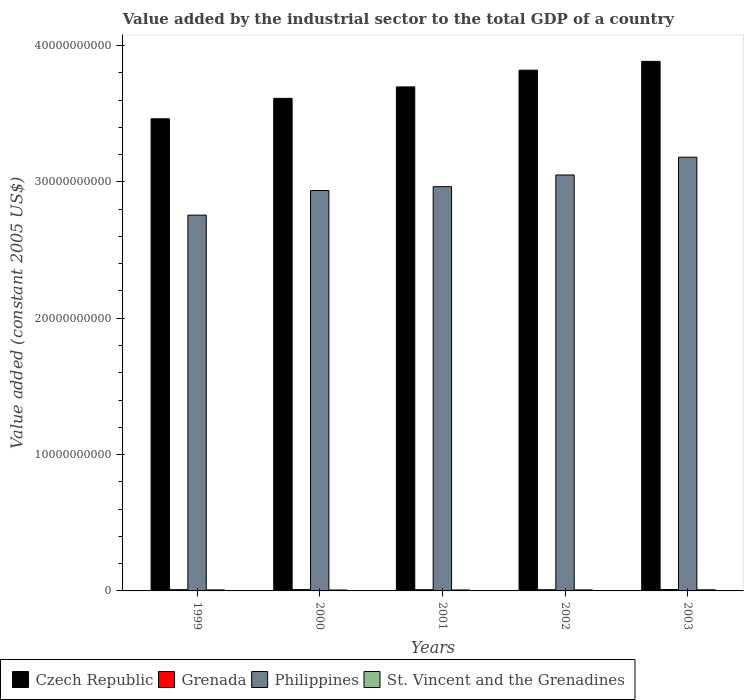How many different coloured bars are there?
Keep it short and to the point. 4. How many groups of bars are there?
Your answer should be very brief. 5. Are the number of bars per tick equal to the number of legend labels?
Offer a terse response. Yes. How many bars are there on the 4th tick from the left?
Offer a very short reply. 4. How many bars are there on the 5th tick from the right?
Your response must be concise. 4. What is the label of the 1st group of bars from the left?
Offer a very short reply. 1999. In how many cases, is the number of bars for a given year not equal to the number of legend labels?
Offer a terse response. 0. What is the value added by the industrial sector in Grenada in 2003?
Your answer should be compact. 1.01e+08. Across all years, what is the maximum value added by the industrial sector in St. Vincent and the Grenadines?
Offer a very short reply. 8.26e+07. Across all years, what is the minimum value added by the industrial sector in Czech Republic?
Give a very brief answer. 3.46e+1. In which year was the value added by the industrial sector in Grenada maximum?
Your answer should be compact. 2003. What is the total value added by the industrial sector in Czech Republic in the graph?
Your answer should be compact. 1.85e+11. What is the difference between the value added by the industrial sector in St. Vincent and the Grenadines in 1999 and that in 2002?
Your answer should be very brief. 2.57e+06. What is the difference between the value added by the industrial sector in Grenada in 2001 and the value added by the industrial sector in Czech Republic in 2002?
Provide a succinct answer. -3.81e+1. What is the average value added by the industrial sector in Grenada per year?
Your response must be concise. 9.32e+07. In the year 2002, what is the difference between the value added by the industrial sector in Philippines and value added by the industrial sector in St. Vincent and the Grenadines?
Provide a short and direct response. 3.04e+1. In how many years, is the value added by the industrial sector in Philippines greater than 20000000000 US$?
Your response must be concise. 5. What is the ratio of the value added by the industrial sector in Grenada in 2001 to that in 2002?
Your answer should be very brief. 0.98. Is the value added by the industrial sector in St. Vincent and the Grenadines in 1999 less than that in 2002?
Provide a short and direct response. No. Is the difference between the value added by the industrial sector in Philippines in 1999 and 2002 greater than the difference between the value added by the industrial sector in St. Vincent and the Grenadines in 1999 and 2002?
Your answer should be very brief. No. What is the difference between the highest and the second highest value added by the industrial sector in Grenada?
Offer a very short reply. 5.77e+06. What is the difference between the highest and the lowest value added by the industrial sector in Philippines?
Keep it short and to the point. 4.25e+09. In how many years, is the value added by the industrial sector in Philippines greater than the average value added by the industrial sector in Philippines taken over all years?
Keep it short and to the point. 2. Is it the case that in every year, the sum of the value added by the industrial sector in Grenada and value added by the industrial sector in St. Vincent and the Grenadines is greater than the sum of value added by the industrial sector in Philippines and value added by the industrial sector in Czech Republic?
Your answer should be compact. Yes. What does the 2nd bar from the left in 2001 represents?
Ensure brevity in your answer.  Grenada. What does the 1st bar from the right in 1999 represents?
Your response must be concise. St. Vincent and the Grenadines. How many bars are there?
Ensure brevity in your answer.  20. Does the graph contain any zero values?
Give a very brief answer. No. Where does the legend appear in the graph?
Make the answer very short. Bottom left. How many legend labels are there?
Offer a very short reply. 4. How are the legend labels stacked?
Give a very brief answer. Horizontal. What is the title of the graph?
Your response must be concise. Value added by the industrial sector to the total GDP of a country. What is the label or title of the X-axis?
Give a very brief answer. Years. What is the label or title of the Y-axis?
Offer a terse response. Value added (constant 2005 US$). What is the Value added (constant 2005 US$) in Czech Republic in 1999?
Your answer should be compact. 3.46e+1. What is the Value added (constant 2005 US$) of Grenada in 1999?
Your response must be concise. 9.29e+07. What is the Value added (constant 2005 US$) of Philippines in 1999?
Your response must be concise. 2.76e+1. What is the Value added (constant 2005 US$) in St. Vincent and the Grenadines in 1999?
Make the answer very short. 7.55e+07. What is the Value added (constant 2005 US$) of Czech Republic in 2000?
Give a very brief answer. 3.61e+1. What is the Value added (constant 2005 US$) in Grenada in 2000?
Give a very brief answer. 9.56e+07. What is the Value added (constant 2005 US$) in Philippines in 2000?
Offer a very short reply. 2.94e+1. What is the Value added (constant 2005 US$) of St. Vincent and the Grenadines in 2000?
Provide a succinct answer. 6.92e+07. What is the Value added (constant 2005 US$) in Czech Republic in 2001?
Your answer should be very brief. 3.70e+1. What is the Value added (constant 2005 US$) in Grenada in 2001?
Your response must be concise. 8.70e+07. What is the Value added (constant 2005 US$) of Philippines in 2001?
Make the answer very short. 2.96e+1. What is the Value added (constant 2005 US$) in St. Vincent and the Grenadines in 2001?
Ensure brevity in your answer.  7.03e+07. What is the Value added (constant 2005 US$) of Czech Republic in 2002?
Your answer should be compact. 3.82e+1. What is the Value added (constant 2005 US$) in Grenada in 2002?
Offer a very short reply. 8.91e+07. What is the Value added (constant 2005 US$) in Philippines in 2002?
Give a very brief answer. 3.05e+1. What is the Value added (constant 2005 US$) of St. Vincent and the Grenadines in 2002?
Your answer should be compact. 7.29e+07. What is the Value added (constant 2005 US$) in Czech Republic in 2003?
Provide a short and direct response. 3.88e+1. What is the Value added (constant 2005 US$) in Grenada in 2003?
Keep it short and to the point. 1.01e+08. What is the Value added (constant 2005 US$) of Philippines in 2003?
Your response must be concise. 3.18e+1. What is the Value added (constant 2005 US$) in St. Vincent and the Grenadines in 2003?
Your response must be concise. 8.26e+07. Across all years, what is the maximum Value added (constant 2005 US$) in Czech Republic?
Give a very brief answer. 3.88e+1. Across all years, what is the maximum Value added (constant 2005 US$) in Grenada?
Ensure brevity in your answer.  1.01e+08. Across all years, what is the maximum Value added (constant 2005 US$) in Philippines?
Your response must be concise. 3.18e+1. Across all years, what is the maximum Value added (constant 2005 US$) of St. Vincent and the Grenadines?
Your answer should be compact. 8.26e+07. Across all years, what is the minimum Value added (constant 2005 US$) of Czech Republic?
Ensure brevity in your answer.  3.46e+1. Across all years, what is the minimum Value added (constant 2005 US$) in Grenada?
Ensure brevity in your answer.  8.70e+07. Across all years, what is the minimum Value added (constant 2005 US$) of Philippines?
Make the answer very short. 2.76e+1. Across all years, what is the minimum Value added (constant 2005 US$) in St. Vincent and the Grenadines?
Keep it short and to the point. 6.92e+07. What is the total Value added (constant 2005 US$) in Czech Republic in the graph?
Offer a very short reply. 1.85e+11. What is the total Value added (constant 2005 US$) in Grenada in the graph?
Keep it short and to the point. 4.66e+08. What is the total Value added (constant 2005 US$) of Philippines in the graph?
Your answer should be very brief. 1.49e+11. What is the total Value added (constant 2005 US$) in St. Vincent and the Grenadines in the graph?
Keep it short and to the point. 3.71e+08. What is the difference between the Value added (constant 2005 US$) of Czech Republic in 1999 and that in 2000?
Your answer should be compact. -1.50e+09. What is the difference between the Value added (constant 2005 US$) of Grenada in 1999 and that in 2000?
Give a very brief answer. -2.69e+06. What is the difference between the Value added (constant 2005 US$) of Philippines in 1999 and that in 2000?
Ensure brevity in your answer.  -1.80e+09. What is the difference between the Value added (constant 2005 US$) of St. Vincent and the Grenadines in 1999 and that in 2000?
Provide a short and direct response. 6.26e+06. What is the difference between the Value added (constant 2005 US$) in Czech Republic in 1999 and that in 2001?
Keep it short and to the point. -2.34e+09. What is the difference between the Value added (constant 2005 US$) of Grenada in 1999 and that in 2001?
Offer a very short reply. 5.90e+06. What is the difference between the Value added (constant 2005 US$) in Philippines in 1999 and that in 2001?
Offer a very short reply. -2.09e+09. What is the difference between the Value added (constant 2005 US$) in St. Vincent and the Grenadines in 1999 and that in 2001?
Your answer should be compact. 5.14e+06. What is the difference between the Value added (constant 2005 US$) in Czech Republic in 1999 and that in 2002?
Your answer should be very brief. -3.57e+09. What is the difference between the Value added (constant 2005 US$) in Grenada in 1999 and that in 2002?
Your response must be concise. 3.80e+06. What is the difference between the Value added (constant 2005 US$) of Philippines in 1999 and that in 2002?
Your response must be concise. -2.94e+09. What is the difference between the Value added (constant 2005 US$) in St. Vincent and the Grenadines in 1999 and that in 2002?
Ensure brevity in your answer.  2.57e+06. What is the difference between the Value added (constant 2005 US$) of Czech Republic in 1999 and that in 2003?
Provide a succinct answer. -4.21e+09. What is the difference between the Value added (constant 2005 US$) in Grenada in 1999 and that in 2003?
Provide a short and direct response. -8.46e+06. What is the difference between the Value added (constant 2005 US$) of Philippines in 1999 and that in 2003?
Give a very brief answer. -4.25e+09. What is the difference between the Value added (constant 2005 US$) in St. Vincent and the Grenadines in 1999 and that in 2003?
Provide a succinct answer. -7.10e+06. What is the difference between the Value added (constant 2005 US$) in Czech Republic in 2000 and that in 2001?
Offer a terse response. -8.39e+08. What is the difference between the Value added (constant 2005 US$) in Grenada in 2000 and that in 2001?
Provide a short and direct response. 8.59e+06. What is the difference between the Value added (constant 2005 US$) in Philippines in 2000 and that in 2001?
Ensure brevity in your answer.  -2.82e+08. What is the difference between the Value added (constant 2005 US$) of St. Vincent and the Grenadines in 2000 and that in 2001?
Offer a very short reply. -1.12e+06. What is the difference between the Value added (constant 2005 US$) in Czech Republic in 2000 and that in 2002?
Ensure brevity in your answer.  -2.07e+09. What is the difference between the Value added (constant 2005 US$) of Grenada in 2000 and that in 2002?
Your response must be concise. 6.49e+06. What is the difference between the Value added (constant 2005 US$) of Philippines in 2000 and that in 2002?
Offer a very short reply. -1.14e+09. What is the difference between the Value added (constant 2005 US$) in St. Vincent and the Grenadines in 2000 and that in 2002?
Provide a short and direct response. -3.69e+06. What is the difference between the Value added (constant 2005 US$) in Czech Republic in 2000 and that in 2003?
Ensure brevity in your answer.  -2.71e+09. What is the difference between the Value added (constant 2005 US$) in Grenada in 2000 and that in 2003?
Keep it short and to the point. -5.77e+06. What is the difference between the Value added (constant 2005 US$) of Philippines in 2000 and that in 2003?
Offer a terse response. -2.44e+09. What is the difference between the Value added (constant 2005 US$) of St. Vincent and the Grenadines in 2000 and that in 2003?
Your answer should be compact. -1.34e+07. What is the difference between the Value added (constant 2005 US$) in Czech Republic in 2001 and that in 2002?
Provide a succinct answer. -1.23e+09. What is the difference between the Value added (constant 2005 US$) of Grenada in 2001 and that in 2002?
Your answer should be compact. -2.10e+06. What is the difference between the Value added (constant 2005 US$) of Philippines in 2001 and that in 2002?
Ensure brevity in your answer.  -8.57e+08. What is the difference between the Value added (constant 2005 US$) of St. Vincent and the Grenadines in 2001 and that in 2002?
Offer a terse response. -2.58e+06. What is the difference between the Value added (constant 2005 US$) in Czech Republic in 2001 and that in 2003?
Keep it short and to the point. -1.87e+09. What is the difference between the Value added (constant 2005 US$) in Grenada in 2001 and that in 2003?
Your answer should be very brief. -1.44e+07. What is the difference between the Value added (constant 2005 US$) in Philippines in 2001 and that in 2003?
Your answer should be very brief. -2.16e+09. What is the difference between the Value added (constant 2005 US$) of St. Vincent and the Grenadines in 2001 and that in 2003?
Provide a short and direct response. -1.22e+07. What is the difference between the Value added (constant 2005 US$) in Czech Republic in 2002 and that in 2003?
Ensure brevity in your answer.  -6.47e+08. What is the difference between the Value added (constant 2005 US$) in Grenada in 2002 and that in 2003?
Keep it short and to the point. -1.23e+07. What is the difference between the Value added (constant 2005 US$) of Philippines in 2002 and that in 2003?
Ensure brevity in your answer.  -1.30e+09. What is the difference between the Value added (constant 2005 US$) of St. Vincent and the Grenadines in 2002 and that in 2003?
Give a very brief answer. -9.67e+06. What is the difference between the Value added (constant 2005 US$) in Czech Republic in 1999 and the Value added (constant 2005 US$) in Grenada in 2000?
Your answer should be very brief. 3.45e+1. What is the difference between the Value added (constant 2005 US$) in Czech Republic in 1999 and the Value added (constant 2005 US$) in Philippines in 2000?
Provide a succinct answer. 5.26e+09. What is the difference between the Value added (constant 2005 US$) of Czech Republic in 1999 and the Value added (constant 2005 US$) of St. Vincent and the Grenadines in 2000?
Ensure brevity in your answer.  3.46e+1. What is the difference between the Value added (constant 2005 US$) in Grenada in 1999 and the Value added (constant 2005 US$) in Philippines in 2000?
Ensure brevity in your answer.  -2.93e+1. What is the difference between the Value added (constant 2005 US$) in Grenada in 1999 and the Value added (constant 2005 US$) in St. Vincent and the Grenadines in 2000?
Offer a very short reply. 2.37e+07. What is the difference between the Value added (constant 2005 US$) of Philippines in 1999 and the Value added (constant 2005 US$) of St. Vincent and the Grenadines in 2000?
Offer a terse response. 2.75e+1. What is the difference between the Value added (constant 2005 US$) in Czech Republic in 1999 and the Value added (constant 2005 US$) in Grenada in 2001?
Provide a succinct answer. 3.45e+1. What is the difference between the Value added (constant 2005 US$) of Czech Republic in 1999 and the Value added (constant 2005 US$) of Philippines in 2001?
Provide a succinct answer. 4.98e+09. What is the difference between the Value added (constant 2005 US$) in Czech Republic in 1999 and the Value added (constant 2005 US$) in St. Vincent and the Grenadines in 2001?
Your answer should be very brief. 3.46e+1. What is the difference between the Value added (constant 2005 US$) of Grenada in 1999 and the Value added (constant 2005 US$) of Philippines in 2001?
Keep it short and to the point. -2.96e+1. What is the difference between the Value added (constant 2005 US$) in Grenada in 1999 and the Value added (constant 2005 US$) in St. Vincent and the Grenadines in 2001?
Your response must be concise. 2.26e+07. What is the difference between the Value added (constant 2005 US$) in Philippines in 1999 and the Value added (constant 2005 US$) in St. Vincent and the Grenadines in 2001?
Provide a short and direct response. 2.75e+1. What is the difference between the Value added (constant 2005 US$) of Czech Republic in 1999 and the Value added (constant 2005 US$) of Grenada in 2002?
Offer a very short reply. 3.45e+1. What is the difference between the Value added (constant 2005 US$) in Czech Republic in 1999 and the Value added (constant 2005 US$) in Philippines in 2002?
Your response must be concise. 4.12e+09. What is the difference between the Value added (constant 2005 US$) in Czech Republic in 1999 and the Value added (constant 2005 US$) in St. Vincent and the Grenadines in 2002?
Offer a very short reply. 3.46e+1. What is the difference between the Value added (constant 2005 US$) in Grenada in 1999 and the Value added (constant 2005 US$) in Philippines in 2002?
Offer a very short reply. -3.04e+1. What is the difference between the Value added (constant 2005 US$) in Grenada in 1999 and the Value added (constant 2005 US$) in St. Vincent and the Grenadines in 2002?
Your answer should be compact. 2.00e+07. What is the difference between the Value added (constant 2005 US$) in Philippines in 1999 and the Value added (constant 2005 US$) in St. Vincent and the Grenadines in 2002?
Your answer should be compact. 2.75e+1. What is the difference between the Value added (constant 2005 US$) in Czech Republic in 1999 and the Value added (constant 2005 US$) in Grenada in 2003?
Ensure brevity in your answer.  3.45e+1. What is the difference between the Value added (constant 2005 US$) of Czech Republic in 1999 and the Value added (constant 2005 US$) of Philippines in 2003?
Give a very brief answer. 2.82e+09. What is the difference between the Value added (constant 2005 US$) in Czech Republic in 1999 and the Value added (constant 2005 US$) in St. Vincent and the Grenadines in 2003?
Give a very brief answer. 3.45e+1. What is the difference between the Value added (constant 2005 US$) in Grenada in 1999 and the Value added (constant 2005 US$) in Philippines in 2003?
Your response must be concise. -3.17e+1. What is the difference between the Value added (constant 2005 US$) of Grenada in 1999 and the Value added (constant 2005 US$) of St. Vincent and the Grenadines in 2003?
Your answer should be compact. 1.03e+07. What is the difference between the Value added (constant 2005 US$) of Philippines in 1999 and the Value added (constant 2005 US$) of St. Vincent and the Grenadines in 2003?
Provide a short and direct response. 2.75e+1. What is the difference between the Value added (constant 2005 US$) in Czech Republic in 2000 and the Value added (constant 2005 US$) in Grenada in 2001?
Your answer should be very brief. 3.60e+1. What is the difference between the Value added (constant 2005 US$) of Czech Republic in 2000 and the Value added (constant 2005 US$) of Philippines in 2001?
Your answer should be compact. 6.48e+09. What is the difference between the Value added (constant 2005 US$) in Czech Republic in 2000 and the Value added (constant 2005 US$) in St. Vincent and the Grenadines in 2001?
Your response must be concise. 3.61e+1. What is the difference between the Value added (constant 2005 US$) in Grenada in 2000 and the Value added (constant 2005 US$) in Philippines in 2001?
Keep it short and to the point. -2.96e+1. What is the difference between the Value added (constant 2005 US$) of Grenada in 2000 and the Value added (constant 2005 US$) of St. Vincent and the Grenadines in 2001?
Your answer should be very brief. 2.52e+07. What is the difference between the Value added (constant 2005 US$) in Philippines in 2000 and the Value added (constant 2005 US$) in St. Vincent and the Grenadines in 2001?
Provide a short and direct response. 2.93e+1. What is the difference between the Value added (constant 2005 US$) of Czech Republic in 2000 and the Value added (constant 2005 US$) of Grenada in 2002?
Provide a short and direct response. 3.60e+1. What is the difference between the Value added (constant 2005 US$) of Czech Republic in 2000 and the Value added (constant 2005 US$) of Philippines in 2002?
Offer a terse response. 5.62e+09. What is the difference between the Value added (constant 2005 US$) in Czech Republic in 2000 and the Value added (constant 2005 US$) in St. Vincent and the Grenadines in 2002?
Provide a succinct answer. 3.60e+1. What is the difference between the Value added (constant 2005 US$) of Grenada in 2000 and the Value added (constant 2005 US$) of Philippines in 2002?
Your response must be concise. -3.04e+1. What is the difference between the Value added (constant 2005 US$) in Grenada in 2000 and the Value added (constant 2005 US$) in St. Vincent and the Grenadines in 2002?
Keep it short and to the point. 2.27e+07. What is the difference between the Value added (constant 2005 US$) of Philippines in 2000 and the Value added (constant 2005 US$) of St. Vincent and the Grenadines in 2002?
Ensure brevity in your answer.  2.93e+1. What is the difference between the Value added (constant 2005 US$) in Czech Republic in 2000 and the Value added (constant 2005 US$) in Grenada in 2003?
Your answer should be compact. 3.60e+1. What is the difference between the Value added (constant 2005 US$) in Czech Republic in 2000 and the Value added (constant 2005 US$) in Philippines in 2003?
Give a very brief answer. 4.32e+09. What is the difference between the Value added (constant 2005 US$) in Czech Republic in 2000 and the Value added (constant 2005 US$) in St. Vincent and the Grenadines in 2003?
Your answer should be very brief. 3.60e+1. What is the difference between the Value added (constant 2005 US$) of Grenada in 2000 and the Value added (constant 2005 US$) of Philippines in 2003?
Offer a terse response. -3.17e+1. What is the difference between the Value added (constant 2005 US$) in Grenada in 2000 and the Value added (constant 2005 US$) in St. Vincent and the Grenadines in 2003?
Offer a terse response. 1.30e+07. What is the difference between the Value added (constant 2005 US$) of Philippines in 2000 and the Value added (constant 2005 US$) of St. Vincent and the Grenadines in 2003?
Make the answer very short. 2.93e+1. What is the difference between the Value added (constant 2005 US$) of Czech Republic in 2001 and the Value added (constant 2005 US$) of Grenada in 2002?
Keep it short and to the point. 3.69e+1. What is the difference between the Value added (constant 2005 US$) in Czech Republic in 2001 and the Value added (constant 2005 US$) in Philippines in 2002?
Offer a terse response. 6.46e+09. What is the difference between the Value added (constant 2005 US$) of Czech Republic in 2001 and the Value added (constant 2005 US$) of St. Vincent and the Grenadines in 2002?
Give a very brief answer. 3.69e+1. What is the difference between the Value added (constant 2005 US$) of Grenada in 2001 and the Value added (constant 2005 US$) of Philippines in 2002?
Your answer should be very brief. -3.04e+1. What is the difference between the Value added (constant 2005 US$) of Grenada in 2001 and the Value added (constant 2005 US$) of St. Vincent and the Grenadines in 2002?
Offer a terse response. 1.41e+07. What is the difference between the Value added (constant 2005 US$) of Philippines in 2001 and the Value added (constant 2005 US$) of St. Vincent and the Grenadines in 2002?
Offer a terse response. 2.96e+1. What is the difference between the Value added (constant 2005 US$) in Czech Republic in 2001 and the Value added (constant 2005 US$) in Grenada in 2003?
Offer a very short reply. 3.69e+1. What is the difference between the Value added (constant 2005 US$) of Czech Republic in 2001 and the Value added (constant 2005 US$) of Philippines in 2003?
Keep it short and to the point. 5.16e+09. What is the difference between the Value added (constant 2005 US$) in Czech Republic in 2001 and the Value added (constant 2005 US$) in St. Vincent and the Grenadines in 2003?
Offer a very short reply. 3.69e+1. What is the difference between the Value added (constant 2005 US$) of Grenada in 2001 and the Value added (constant 2005 US$) of Philippines in 2003?
Give a very brief answer. -3.17e+1. What is the difference between the Value added (constant 2005 US$) of Grenada in 2001 and the Value added (constant 2005 US$) of St. Vincent and the Grenadines in 2003?
Your answer should be very brief. 4.41e+06. What is the difference between the Value added (constant 2005 US$) in Philippines in 2001 and the Value added (constant 2005 US$) in St. Vincent and the Grenadines in 2003?
Offer a terse response. 2.96e+1. What is the difference between the Value added (constant 2005 US$) in Czech Republic in 2002 and the Value added (constant 2005 US$) in Grenada in 2003?
Provide a short and direct response. 3.81e+1. What is the difference between the Value added (constant 2005 US$) in Czech Republic in 2002 and the Value added (constant 2005 US$) in Philippines in 2003?
Provide a succinct answer. 6.38e+09. What is the difference between the Value added (constant 2005 US$) in Czech Republic in 2002 and the Value added (constant 2005 US$) in St. Vincent and the Grenadines in 2003?
Your response must be concise. 3.81e+1. What is the difference between the Value added (constant 2005 US$) of Grenada in 2002 and the Value added (constant 2005 US$) of Philippines in 2003?
Make the answer very short. -3.17e+1. What is the difference between the Value added (constant 2005 US$) of Grenada in 2002 and the Value added (constant 2005 US$) of St. Vincent and the Grenadines in 2003?
Provide a short and direct response. 6.51e+06. What is the difference between the Value added (constant 2005 US$) of Philippines in 2002 and the Value added (constant 2005 US$) of St. Vincent and the Grenadines in 2003?
Make the answer very short. 3.04e+1. What is the average Value added (constant 2005 US$) in Czech Republic per year?
Provide a succinct answer. 3.69e+1. What is the average Value added (constant 2005 US$) of Grenada per year?
Provide a short and direct response. 9.32e+07. What is the average Value added (constant 2005 US$) of Philippines per year?
Provide a short and direct response. 2.98e+1. What is the average Value added (constant 2005 US$) of St. Vincent and the Grenadines per year?
Offer a terse response. 7.41e+07. In the year 1999, what is the difference between the Value added (constant 2005 US$) in Czech Republic and Value added (constant 2005 US$) in Grenada?
Offer a very short reply. 3.45e+1. In the year 1999, what is the difference between the Value added (constant 2005 US$) of Czech Republic and Value added (constant 2005 US$) of Philippines?
Give a very brief answer. 7.06e+09. In the year 1999, what is the difference between the Value added (constant 2005 US$) of Czech Republic and Value added (constant 2005 US$) of St. Vincent and the Grenadines?
Make the answer very short. 3.45e+1. In the year 1999, what is the difference between the Value added (constant 2005 US$) in Grenada and Value added (constant 2005 US$) in Philippines?
Your answer should be very brief. -2.75e+1. In the year 1999, what is the difference between the Value added (constant 2005 US$) in Grenada and Value added (constant 2005 US$) in St. Vincent and the Grenadines?
Your response must be concise. 1.74e+07. In the year 1999, what is the difference between the Value added (constant 2005 US$) of Philippines and Value added (constant 2005 US$) of St. Vincent and the Grenadines?
Your response must be concise. 2.75e+1. In the year 2000, what is the difference between the Value added (constant 2005 US$) in Czech Republic and Value added (constant 2005 US$) in Grenada?
Provide a succinct answer. 3.60e+1. In the year 2000, what is the difference between the Value added (constant 2005 US$) in Czech Republic and Value added (constant 2005 US$) in Philippines?
Keep it short and to the point. 6.76e+09. In the year 2000, what is the difference between the Value added (constant 2005 US$) in Czech Republic and Value added (constant 2005 US$) in St. Vincent and the Grenadines?
Make the answer very short. 3.61e+1. In the year 2000, what is the difference between the Value added (constant 2005 US$) of Grenada and Value added (constant 2005 US$) of Philippines?
Ensure brevity in your answer.  -2.93e+1. In the year 2000, what is the difference between the Value added (constant 2005 US$) of Grenada and Value added (constant 2005 US$) of St. Vincent and the Grenadines?
Your answer should be very brief. 2.64e+07. In the year 2000, what is the difference between the Value added (constant 2005 US$) of Philippines and Value added (constant 2005 US$) of St. Vincent and the Grenadines?
Keep it short and to the point. 2.93e+1. In the year 2001, what is the difference between the Value added (constant 2005 US$) in Czech Republic and Value added (constant 2005 US$) in Grenada?
Make the answer very short. 3.69e+1. In the year 2001, what is the difference between the Value added (constant 2005 US$) in Czech Republic and Value added (constant 2005 US$) in Philippines?
Offer a very short reply. 7.32e+09. In the year 2001, what is the difference between the Value added (constant 2005 US$) in Czech Republic and Value added (constant 2005 US$) in St. Vincent and the Grenadines?
Ensure brevity in your answer.  3.69e+1. In the year 2001, what is the difference between the Value added (constant 2005 US$) of Grenada and Value added (constant 2005 US$) of Philippines?
Ensure brevity in your answer.  -2.96e+1. In the year 2001, what is the difference between the Value added (constant 2005 US$) in Grenada and Value added (constant 2005 US$) in St. Vincent and the Grenadines?
Give a very brief answer. 1.67e+07. In the year 2001, what is the difference between the Value added (constant 2005 US$) of Philippines and Value added (constant 2005 US$) of St. Vincent and the Grenadines?
Ensure brevity in your answer.  2.96e+1. In the year 2002, what is the difference between the Value added (constant 2005 US$) in Czech Republic and Value added (constant 2005 US$) in Grenada?
Your response must be concise. 3.81e+1. In the year 2002, what is the difference between the Value added (constant 2005 US$) in Czech Republic and Value added (constant 2005 US$) in Philippines?
Give a very brief answer. 7.69e+09. In the year 2002, what is the difference between the Value added (constant 2005 US$) in Czech Republic and Value added (constant 2005 US$) in St. Vincent and the Grenadines?
Provide a succinct answer. 3.81e+1. In the year 2002, what is the difference between the Value added (constant 2005 US$) in Grenada and Value added (constant 2005 US$) in Philippines?
Your response must be concise. -3.04e+1. In the year 2002, what is the difference between the Value added (constant 2005 US$) in Grenada and Value added (constant 2005 US$) in St. Vincent and the Grenadines?
Make the answer very short. 1.62e+07. In the year 2002, what is the difference between the Value added (constant 2005 US$) of Philippines and Value added (constant 2005 US$) of St. Vincent and the Grenadines?
Give a very brief answer. 3.04e+1. In the year 2003, what is the difference between the Value added (constant 2005 US$) in Czech Republic and Value added (constant 2005 US$) in Grenada?
Provide a succinct answer. 3.87e+1. In the year 2003, what is the difference between the Value added (constant 2005 US$) in Czech Republic and Value added (constant 2005 US$) in Philippines?
Offer a very short reply. 7.03e+09. In the year 2003, what is the difference between the Value added (constant 2005 US$) in Czech Republic and Value added (constant 2005 US$) in St. Vincent and the Grenadines?
Provide a short and direct response. 3.88e+1. In the year 2003, what is the difference between the Value added (constant 2005 US$) in Grenada and Value added (constant 2005 US$) in Philippines?
Ensure brevity in your answer.  -3.17e+1. In the year 2003, what is the difference between the Value added (constant 2005 US$) of Grenada and Value added (constant 2005 US$) of St. Vincent and the Grenadines?
Offer a terse response. 1.88e+07. In the year 2003, what is the difference between the Value added (constant 2005 US$) of Philippines and Value added (constant 2005 US$) of St. Vincent and the Grenadines?
Provide a short and direct response. 3.17e+1. What is the ratio of the Value added (constant 2005 US$) of Czech Republic in 1999 to that in 2000?
Ensure brevity in your answer.  0.96. What is the ratio of the Value added (constant 2005 US$) in Grenada in 1999 to that in 2000?
Keep it short and to the point. 0.97. What is the ratio of the Value added (constant 2005 US$) of Philippines in 1999 to that in 2000?
Make the answer very short. 0.94. What is the ratio of the Value added (constant 2005 US$) in St. Vincent and the Grenadines in 1999 to that in 2000?
Your answer should be compact. 1.09. What is the ratio of the Value added (constant 2005 US$) in Czech Republic in 1999 to that in 2001?
Provide a short and direct response. 0.94. What is the ratio of the Value added (constant 2005 US$) of Grenada in 1999 to that in 2001?
Offer a very short reply. 1.07. What is the ratio of the Value added (constant 2005 US$) of Philippines in 1999 to that in 2001?
Your answer should be compact. 0.93. What is the ratio of the Value added (constant 2005 US$) of St. Vincent and the Grenadines in 1999 to that in 2001?
Your response must be concise. 1.07. What is the ratio of the Value added (constant 2005 US$) in Czech Republic in 1999 to that in 2002?
Your response must be concise. 0.91. What is the ratio of the Value added (constant 2005 US$) in Grenada in 1999 to that in 2002?
Provide a succinct answer. 1.04. What is the ratio of the Value added (constant 2005 US$) of Philippines in 1999 to that in 2002?
Give a very brief answer. 0.9. What is the ratio of the Value added (constant 2005 US$) of St. Vincent and the Grenadines in 1999 to that in 2002?
Give a very brief answer. 1.04. What is the ratio of the Value added (constant 2005 US$) of Czech Republic in 1999 to that in 2003?
Keep it short and to the point. 0.89. What is the ratio of the Value added (constant 2005 US$) of Grenada in 1999 to that in 2003?
Offer a very short reply. 0.92. What is the ratio of the Value added (constant 2005 US$) in Philippines in 1999 to that in 2003?
Ensure brevity in your answer.  0.87. What is the ratio of the Value added (constant 2005 US$) in St. Vincent and the Grenadines in 1999 to that in 2003?
Offer a terse response. 0.91. What is the ratio of the Value added (constant 2005 US$) of Czech Republic in 2000 to that in 2001?
Your answer should be very brief. 0.98. What is the ratio of the Value added (constant 2005 US$) in Grenada in 2000 to that in 2001?
Your answer should be compact. 1.1. What is the ratio of the Value added (constant 2005 US$) of Philippines in 2000 to that in 2001?
Keep it short and to the point. 0.99. What is the ratio of the Value added (constant 2005 US$) in St. Vincent and the Grenadines in 2000 to that in 2001?
Keep it short and to the point. 0.98. What is the ratio of the Value added (constant 2005 US$) in Czech Republic in 2000 to that in 2002?
Your answer should be very brief. 0.95. What is the ratio of the Value added (constant 2005 US$) in Grenada in 2000 to that in 2002?
Offer a very short reply. 1.07. What is the ratio of the Value added (constant 2005 US$) in Philippines in 2000 to that in 2002?
Keep it short and to the point. 0.96. What is the ratio of the Value added (constant 2005 US$) in St. Vincent and the Grenadines in 2000 to that in 2002?
Your answer should be compact. 0.95. What is the ratio of the Value added (constant 2005 US$) of Czech Republic in 2000 to that in 2003?
Your answer should be compact. 0.93. What is the ratio of the Value added (constant 2005 US$) of Grenada in 2000 to that in 2003?
Keep it short and to the point. 0.94. What is the ratio of the Value added (constant 2005 US$) in Philippines in 2000 to that in 2003?
Your answer should be compact. 0.92. What is the ratio of the Value added (constant 2005 US$) in St. Vincent and the Grenadines in 2000 to that in 2003?
Make the answer very short. 0.84. What is the ratio of the Value added (constant 2005 US$) in Czech Republic in 2001 to that in 2002?
Provide a short and direct response. 0.97. What is the ratio of the Value added (constant 2005 US$) in Grenada in 2001 to that in 2002?
Offer a terse response. 0.98. What is the ratio of the Value added (constant 2005 US$) in Philippines in 2001 to that in 2002?
Offer a very short reply. 0.97. What is the ratio of the Value added (constant 2005 US$) of St. Vincent and the Grenadines in 2001 to that in 2002?
Your answer should be compact. 0.96. What is the ratio of the Value added (constant 2005 US$) of Czech Republic in 2001 to that in 2003?
Your answer should be very brief. 0.95. What is the ratio of the Value added (constant 2005 US$) of Grenada in 2001 to that in 2003?
Keep it short and to the point. 0.86. What is the ratio of the Value added (constant 2005 US$) of Philippines in 2001 to that in 2003?
Offer a terse response. 0.93. What is the ratio of the Value added (constant 2005 US$) of St. Vincent and the Grenadines in 2001 to that in 2003?
Give a very brief answer. 0.85. What is the ratio of the Value added (constant 2005 US$) of Czech Republic in 2002 to that in 2003?
Your response must be concise. 0.98. What is the ratio of the Value added (constant 2005 US$) of Grenada in 2002 to that in 2003?
Your answer should be compact. 0.88. What is the ratio of the Value added (constant 2005 US$) of St. Vincent and the Grenadines in 2002 to that in 2003?
Your answer should be very brief. 0.88. What is the difference between the highest and the second highest Value added (constant 2005 US$) of Czech Republic?
Ensure brevity in your answer.  6.47e+08. What is the difference between the highest and the second highest Value added (constant 2005 US$) of Grenada?
Your answer should be very brief. 5.77e+06. What is the difference between the highest and the second highest Value added (constant 2005 US$) of Philippines?
Offer a very short reply. 1.30e+09. What is the difference between the highest and the second highest Value added (constant 2005 US$) in St. Vincent and the Grenadines?
Provide a succinct answer. 7.10e+06. What is the difference between the highest and the lowest Value added (constant 2005 US$) in Czech Republic?
Provide a short and direct response. 4.21e+09. What is the difference between the highest and the lowest Value added (constant 2005 US$) of Grenada?
Your answer should be very brief. 1.44e+07. What is the difference between the highest and the lowest Value added (constant 2005 US$) of Philippines?
Your answer should be compact. 4.25e+09. What is the difference between the highest and the lowest Value added (constant 2005 US$) of St. Vincent and the Grenadines?
Provide a short and direct response. 1.34e+07. 